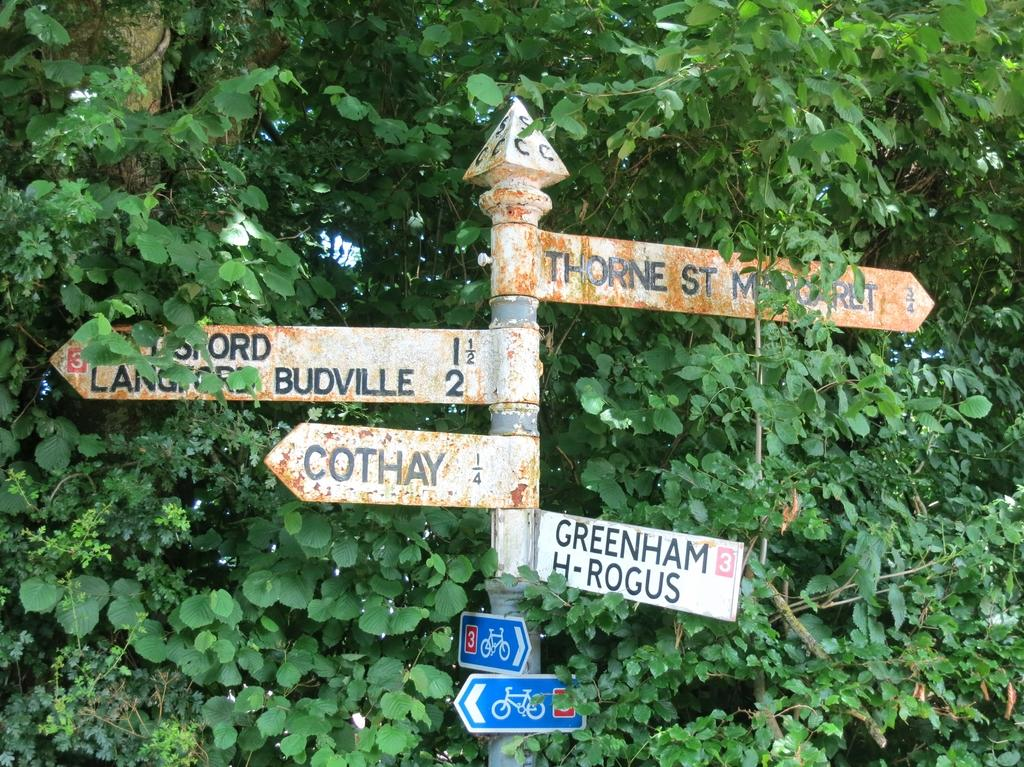What is located in the middle of the image? There is a metal pole in the middle of the image. What is attached to the metal pole? There are hoardings on the metal pole. What can be seen in the background of the image? There are trees and plants in the background of the image. What type of authority figure can be seen rubbing the metal pole in the image? There is no authority figure present in the image, nor is anyone rubbing the metal pole. 